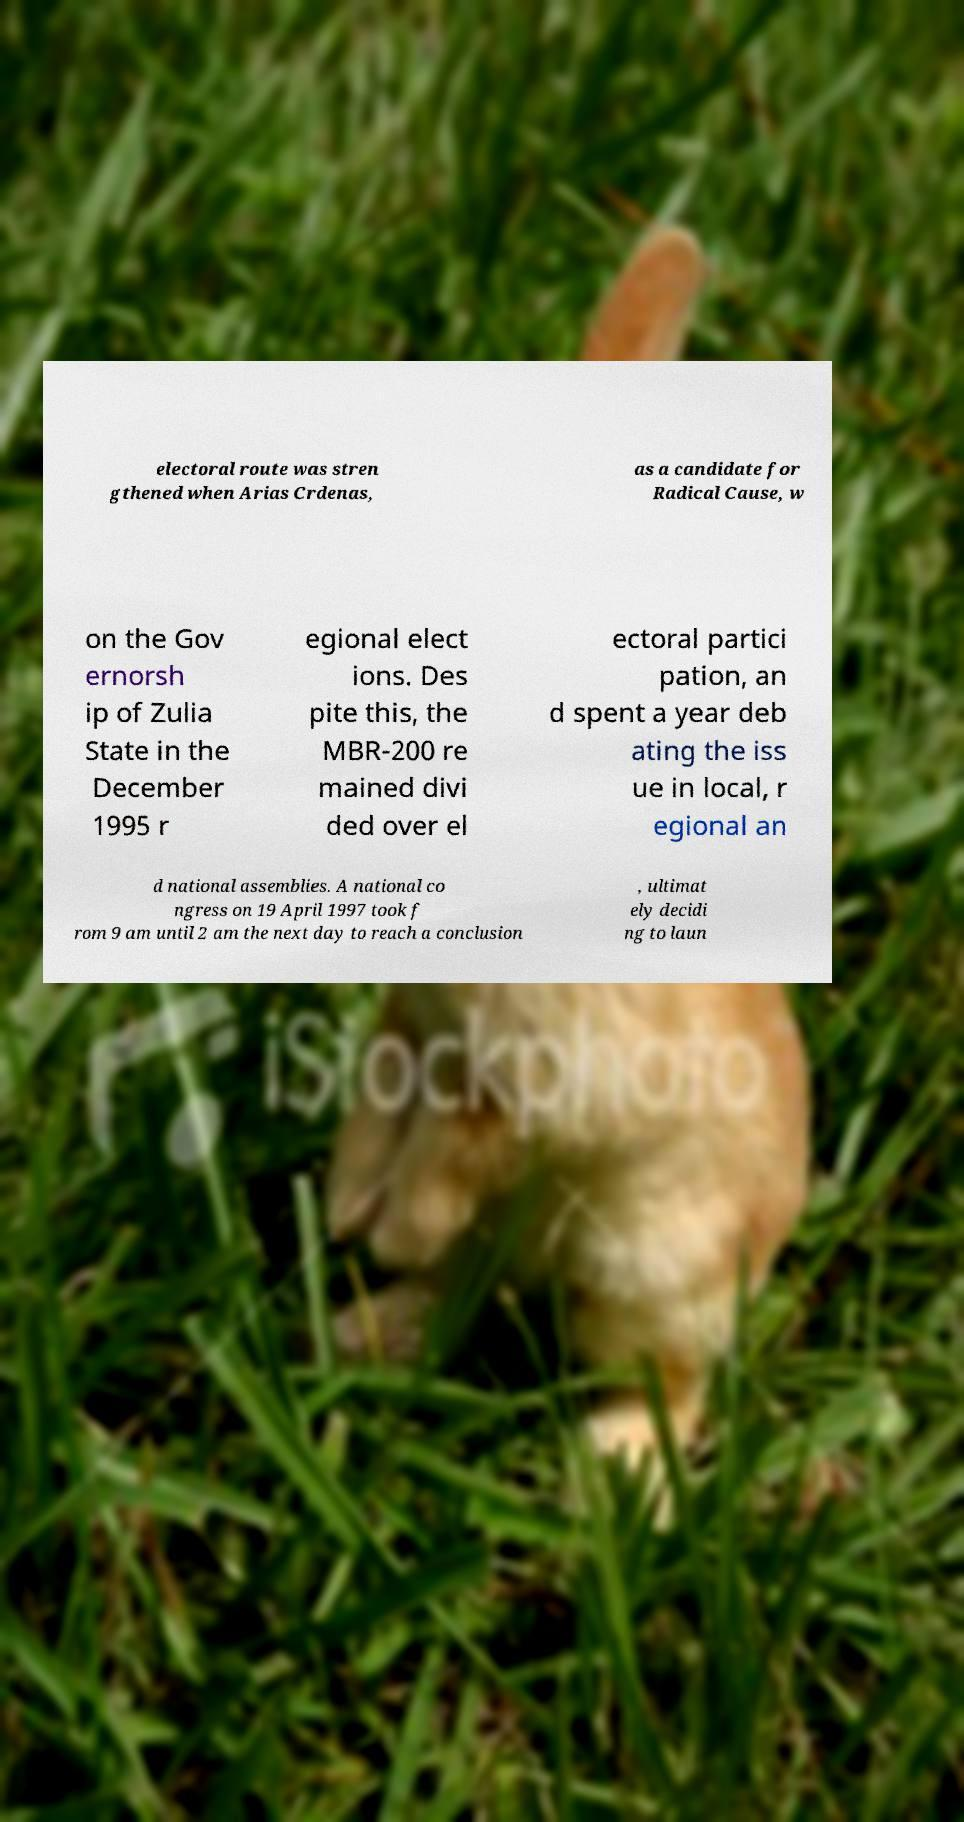Please identify and transcribe the text found in this image. electoral route was stren gthened when Arias Crdenas, as a candidate for Radical Cause, w on the Gov ernorsh ip of Zulia State in the December 1995 r egional elect ions. Des pite this, the MBR-200 re mained divi ded over el ectoral partici pation, an d spent a year deb ating the iss ue in local, r egional an d national assemblies. A national co ngress on 19 April 1997 took f rom 9 am until 2 am the next day to reach a conclusion , ultimat ely decidi ng to laun 